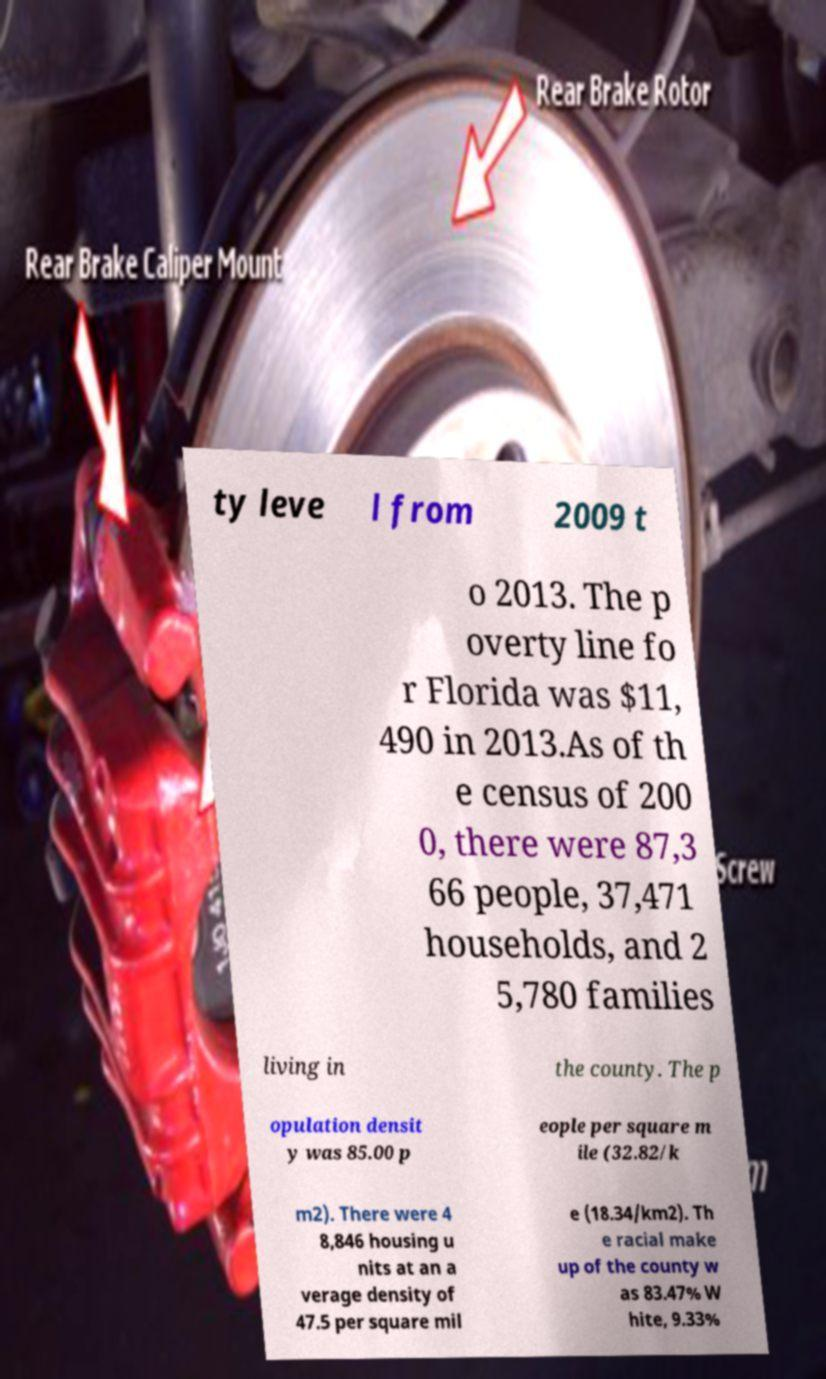Could you extract and type out the text from this image? ty leve l from 2009 t o 2013. The p overty line fo r Florida was $11, 490 in 2013.As of th e census of 200 0, there were 87,3 66 people, 37,471 households, and 2 5,780 families living in the county. The p opulation densit y was 85.00 p eople per square m ile (32.82/k m2). There were 4 8,846 housing u nits at an a verage density of 47.5 per square mil e (18.34/km2). Th e racial make up of the county w as 83.47% W hite, 9.33% 